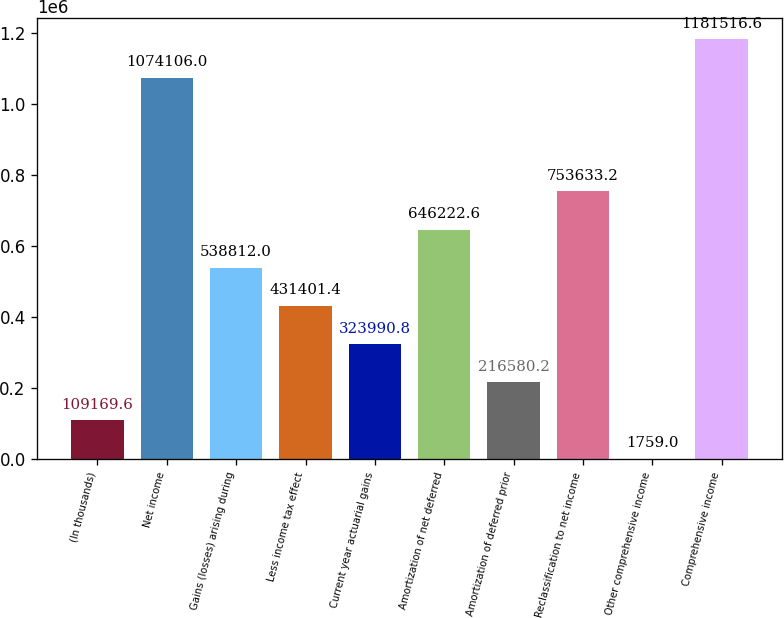<chart> <loc_0><loc_0><loc_500><loc_500><bar_chart><fcel>(In thousands)<fcel>Net income<fcel>Gains (losses) arising during<fcel>Less income tax effect<fcel>Current year actuarial gains<fcel>Amortization of net deferred<fcel>Amortization of deferred prior<fcel>Reclassification to net income<fcel>Other comprehensive income<fcel>Comprehensive income<nl><fcel>109170<fcel>1.07411e+06<fcel>538812<fcel>431401<fcel>323991<fcel>646223<fcel>216580<fcel>753633<fcel>1759<fcel>1.18152e+06<nl></chart> 